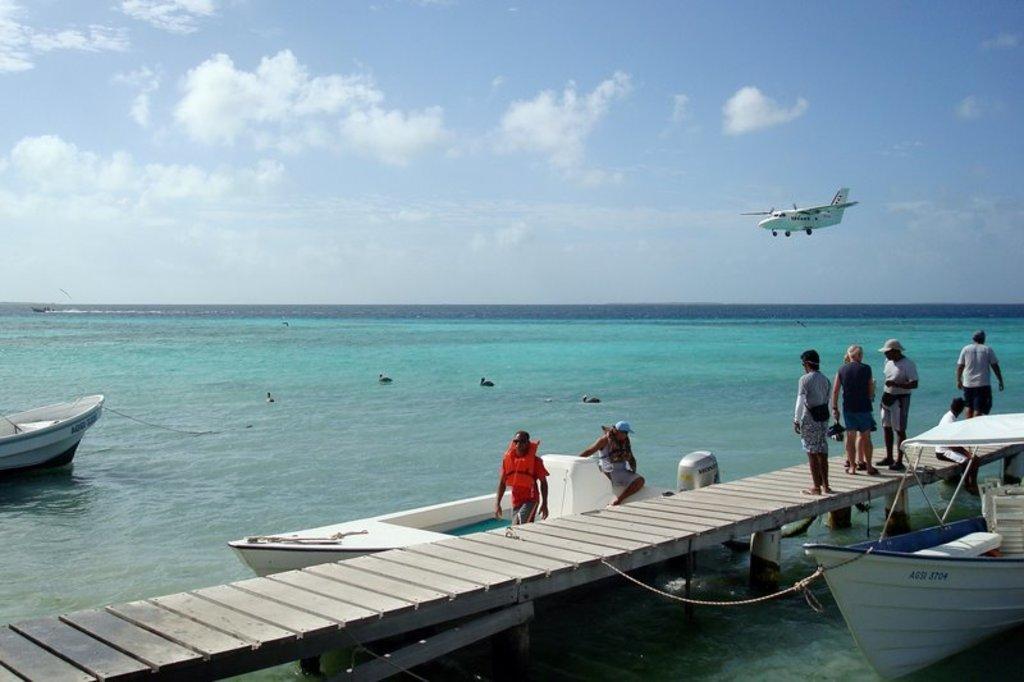Please provide a concise description of this image. In this picture I can see there is a bridge and there are some people standing on the bridge. There are some boats are tied to the bridge and there is a air plane, a ocean, the sky is clear. 